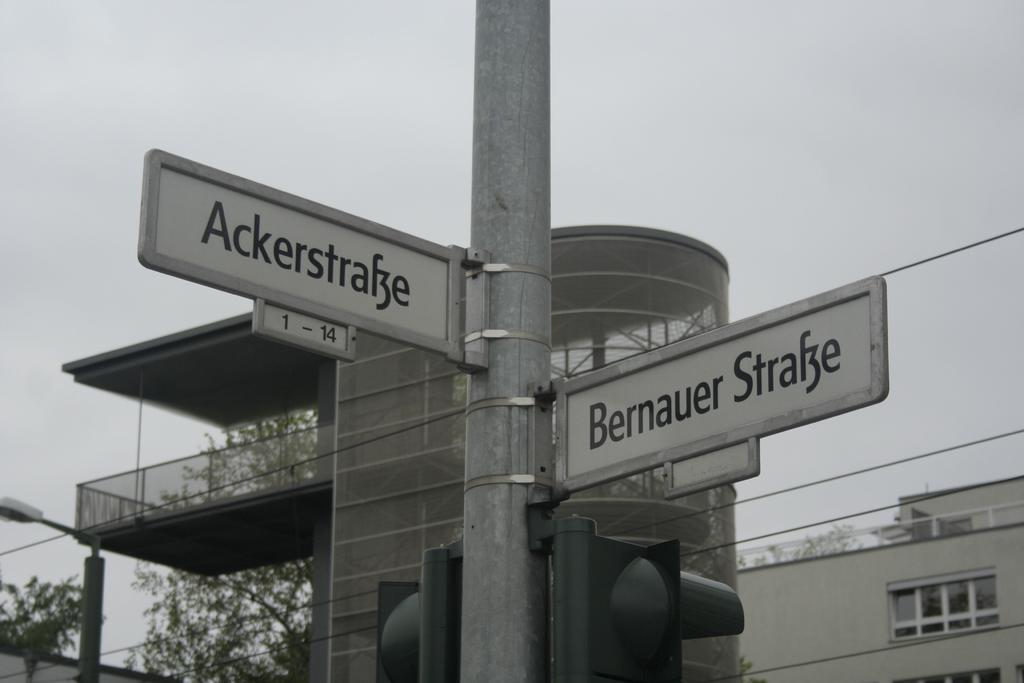What number range is below the sign on the left?
Ensure brevity in your answer.  1-14. 